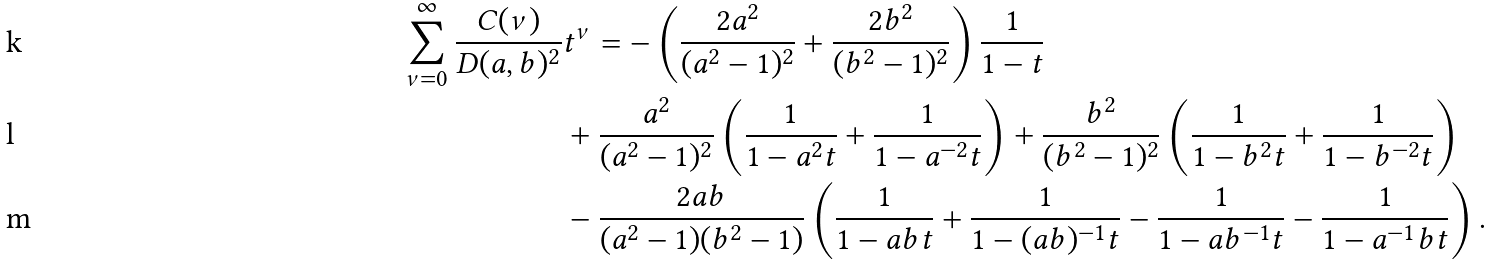Convert formula to latex. <formula><loc_0><loc_0><loc_500><loc_500>\sum _ { \nu = 0 } ^ { \infty } \frac { C ( \nu ) } { D ( a , b ) ^ { 2 } } & t ^ { \nu } = - \left ( \frac { 2 a ^ { 2 } } { ( a ^ { 2 } - 1 ) ^ { 2 } } + \frac { 2 b ^ { 2 } } { ( b ^ { 2 } - 1 ) ^ { 2 } } \right ) \frac { 1 } { 1 - t } \\ & + \frac { a ^ { 2 } } { ( a ^ { 2 } - 1 ) ^ { 2 } } \left ( \frac { 1 } { 1 - a ^ { 2 } t } + \frac { 1 } { 1 - a ^ { - 2 } t } \right ) + \frac { b ^ { 2 } } { ( b ^ { 2 } - 1 ) ^ { 2 } } \left ( \frac { 1 } { 1 - b ^ { 2 } t } + \frac { 1 } { 1 - b ^ { - 2 } t } \right ) \\ & - \frac { 2 a b } { ( a ^ { 2 } - 1 ) ( b ^ { 2 } - 1 ) } \left ( \frac { 1 } { 1 - a b t } + \frac { 1 } { 1 - ( a b ) ^ { - 1 } t } - \frac { 1 } { 1 - a b ^ { - 1 } t } - \frac { 1 } { 1 - a ^ { - 1 } b t } \right ) .</formula> 